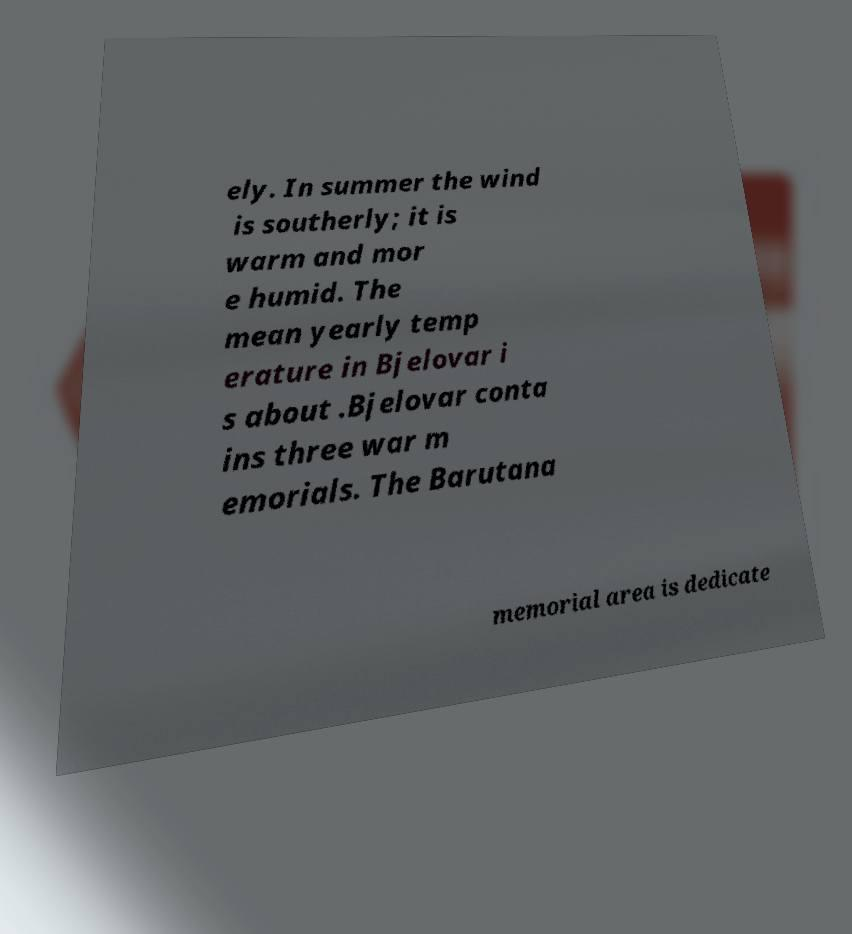I need the written content from this picture converted into text. Can you do that? ely. In summer the wind is southerly; it is warm and mor e humid. The mean yearly temp erature in Bjelovar i s about .Bjelovar conta ins three war m emorials. The Barutana memorial area is dedicate 